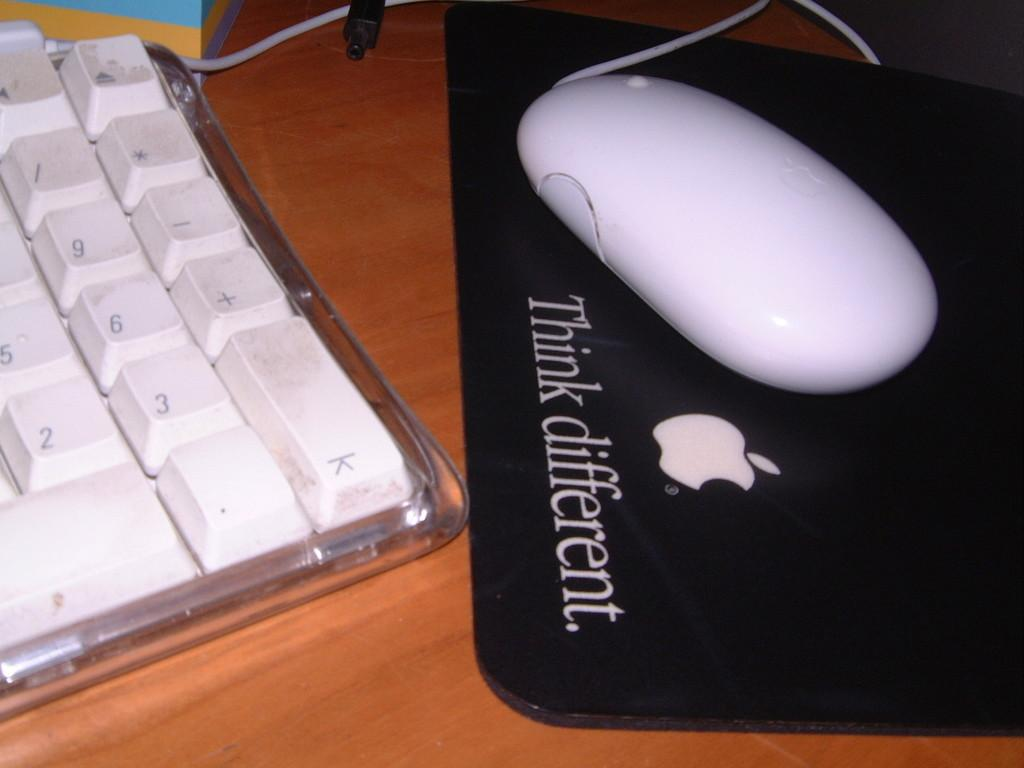<image>
Create a compact narrative representing the image presented. White mouse on top of a black mouse pad that says Think Different. 